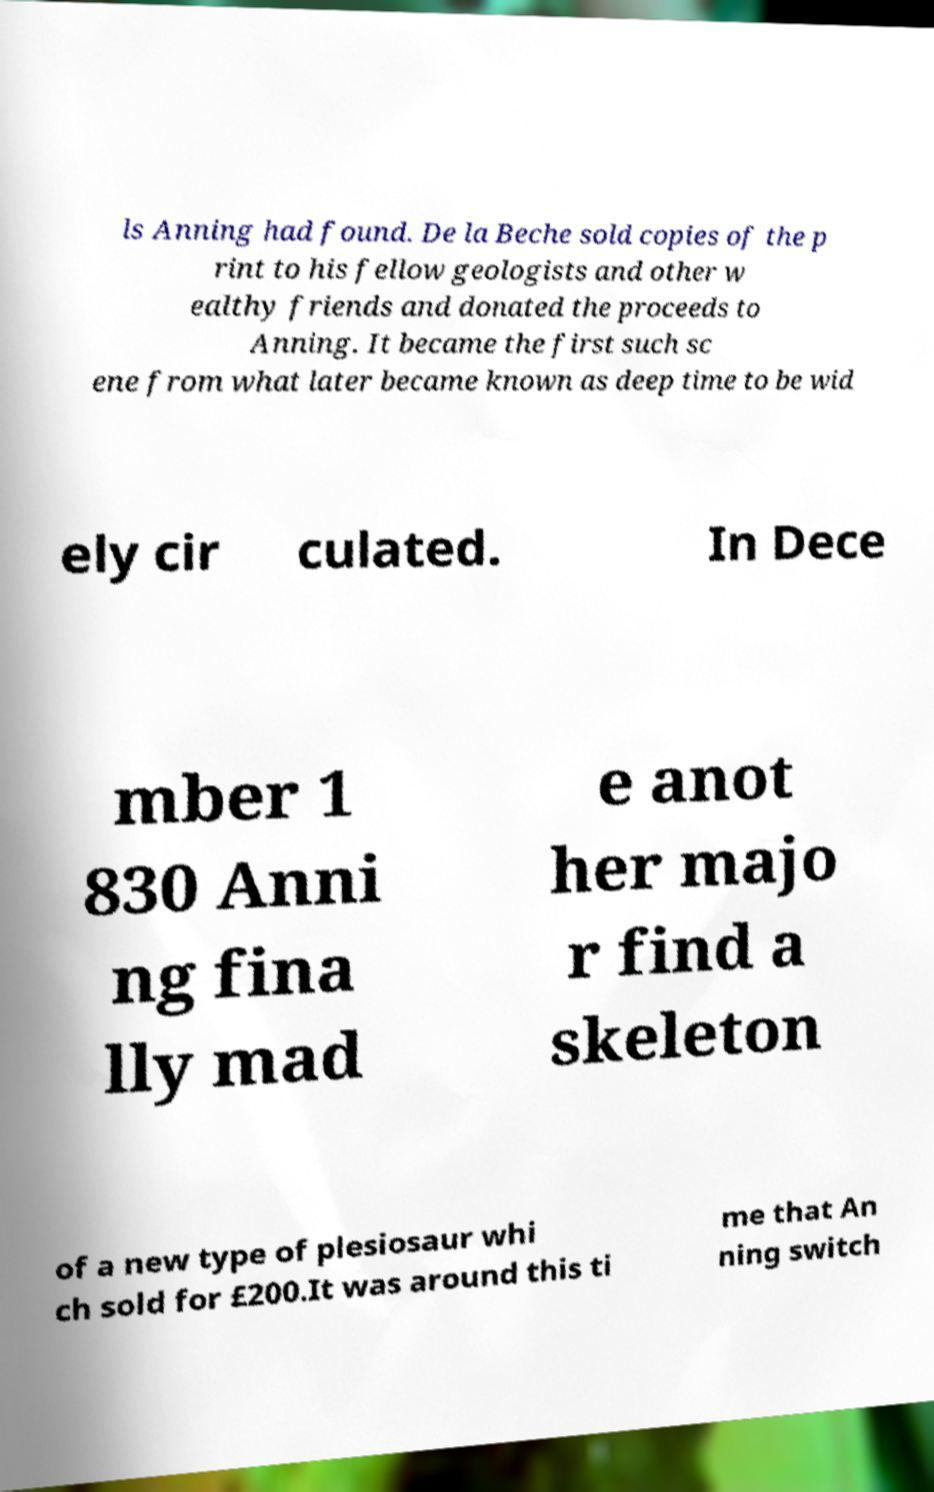There's text embedded in this image that I need extracted. Can you transcribe it verbatim? ls Anning had found. De la Beche sold copies of the p rint to his fellow geologists and other w ealthy friends and donated the proceeds to Anning. It became the first such sc ene from what later became known as deep time to be wid ely cir culated. In Dece mber 1 830 Anni ng fina lly mad e anot her majo r find a skeleton of a new type of plesiosaur whi ch sold for £200.It was around this ti me that An ning switch 